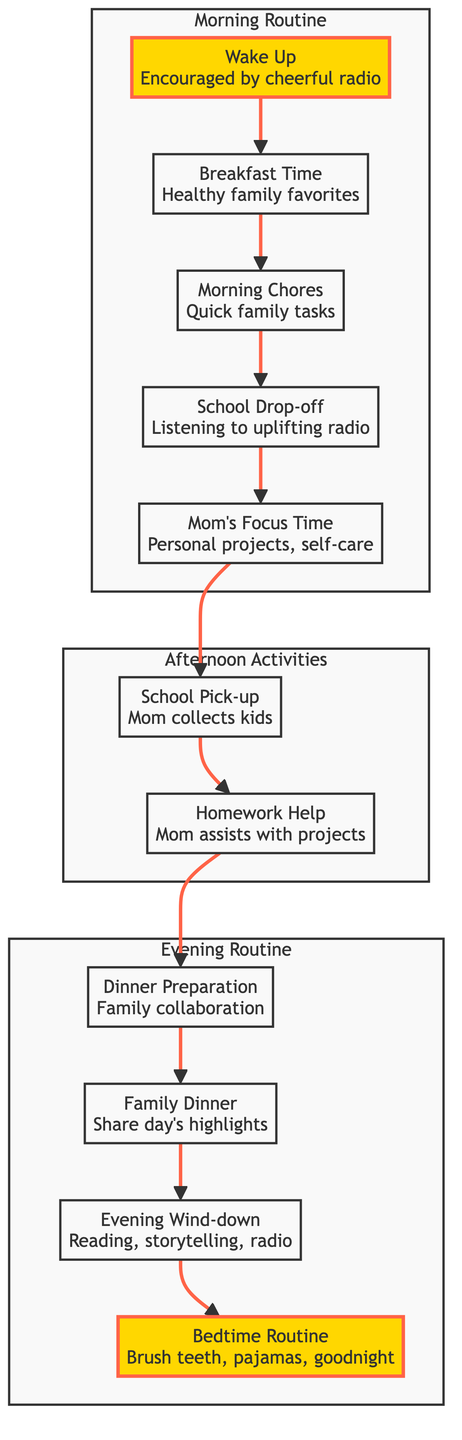What is the first activity in the morning routine? The first activity listed in the morning routine is "Wake Up." It is the starting point of the day for the family.
Answer: Wake Up How many main sections are in the flow chart? The flow chart is divided into three main sections: Morning Routine, Afternoon Activities, and Evening Routine. Counting these sections gives us three.
Answer: 3 What activity follows "School Drop-off"? After "School Drop-off," the next activity is "Mom's Focus Time," indicating that following the drop-off, the mom has dedicated time for herself.
Answer: Mom's Focus Time What is the last activity before bedtime? The last activity before bedtime is "Bedtime Routine," which includes brushing teeth, putting on pajamas, and saying goodnight. This concludes the family's daily activities.
Answer: Bedtime Routine Which activity involves family collaboration? The activity that involves family collaboration is "Dinner Preparation," where the family works together to prepare meals.
Answer: Dinner Preparation How many activities occur in the afternoon section? In the afternoon section, there are three activities: "School Pick-up," "Homework Help," and "Dinner Preparation." Counting these activities gives us three.
Answer: 3 What is the relationship between "Family Dinner" and "Evening Wind-down"? The relationship is that "Family Dinner" leads to "Evening Wind-down," meaning after they share their meal, the family transitions to activities like reading or listening to the radio.
Answer: Family Dinner leads to Evening Wind-down Which activity comes directly after "Homework Help"? Directly following "Homework Help" is "Dinner Preparation," indicating the flow from assisting the kids to preparing for the evening meal.
Answer: Dinner Preparation What is the common theme in the morning routine? The common theme in the morning routine is family togetherness, indicated by activities such as waking up together, having breakfast as a family, and completing morning chores collectively.
Answer: Family togetherness 